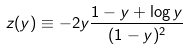<formula> <loc_0><loc_0><loc_500><loc_500>z ( y ) \equiv - 2 y \frac { 1 - y + \log y } { ( 1 - y ) ^ { 2 } }</formula> 